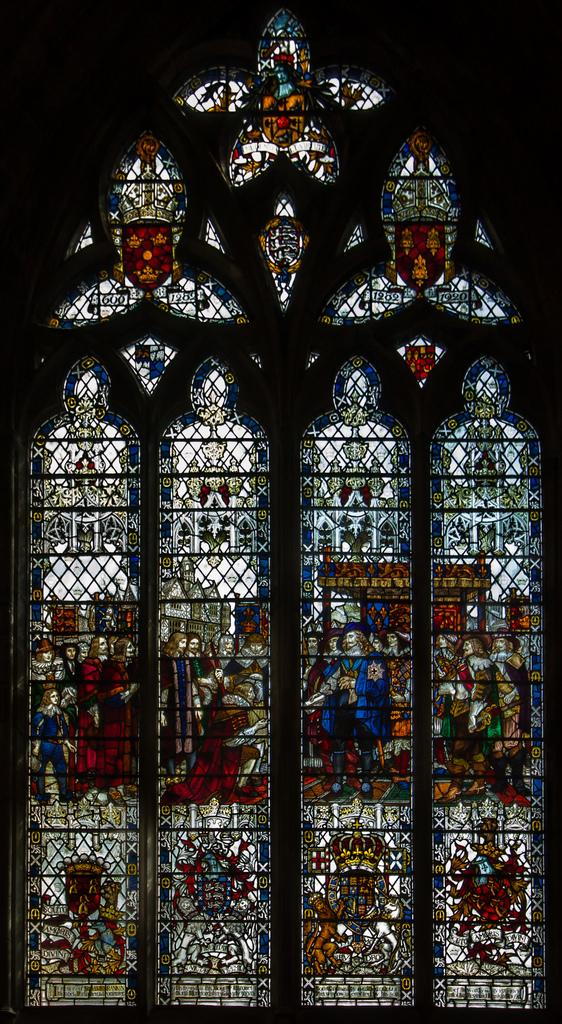What is located in the foreground of the image? There are windows in the foreground of the image. What can be seen in the image besides the windows? There is some art visible in the image. What color is the background of the image? The background of the image is black. What type of toothbrush is featured in the art in the image? There is no toothbrush present in the image, as the art cannot be clearly identified or described from the provided facts. 